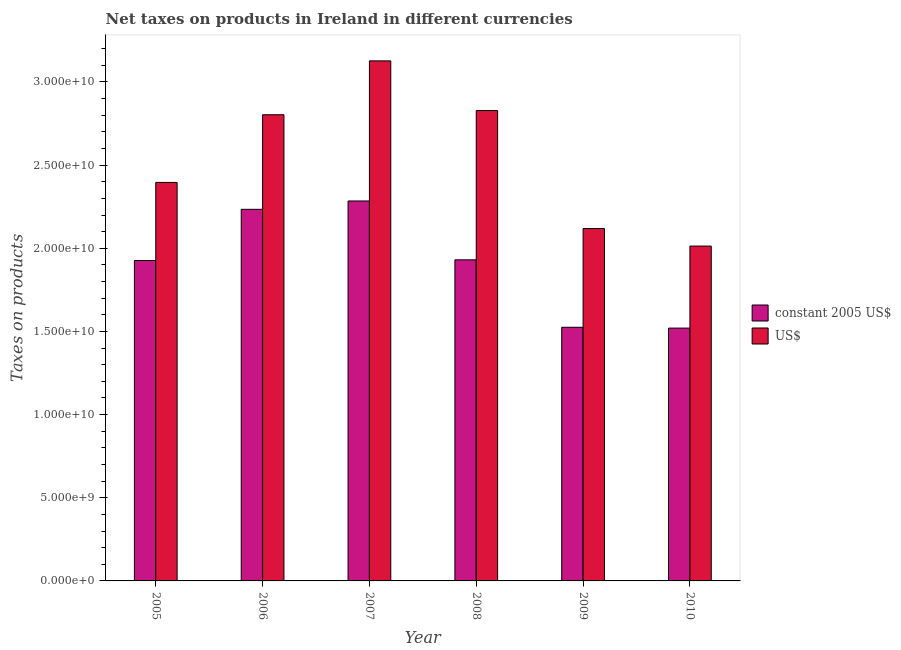How many different coloured bars are there?
Offer a very short reply. 2. Are the number of bars on each tick of the X-axis equal?
Your answer should be compact. Yes. In how many cases, is the number of bars for a given year not equal to the number of legend labels?
Provide a succinct answer. 0. What is the net taxes in us$ in 2008?
Your answer should be compact. 2.83e+1. Across all years, what is the maximum net taxes in us$?
Your answer should be very brief. 3.13e+1. Across all years, what is the minimum net taxes in us$?
Give a very brief answer. 2.01e+1. In which year was the net taxes in constant 2005 us$ maximum?
Keep it short and to the point. 2007. What is the total net taxes in us$ in the graph?
Your response must be concise. 1.53e+11. What is the difference between the net taxes in us$ in 2006 and that in 2010?
Ensure brevity in your answer.  7.90e+09. What is the difference between the net taxes in us$ in 2005 and the net taxes in constant 2005 us$ in 2006?
Offer a terse response. -4.07e+09. What is the average net taxes in us$ per year?
Give a very brief answer. 2.55e+1. In the year 2008, what is the difference between the net taxes in constant 2005 us$ and net taxes in us$?
Your response must be concise. 0. In how many years, is the net taxes in constant 2005 us$ greater than 21000000000 units?
Offer a terse response. 2. What is the ratio of the net taxes in us$ in 2005 to that in 2007?
Offer a terse response. 0.77. Is the net taxes in us$ in 2006 less than that in 2010?
Your answer should be very brief. No. Is the difference between the net taxes in us$ in 2008 and 2010 greater than the difference between the net taxes in constant 2005 us$ in 2008 and 2010?
Offer a terse response. No. What is the difference between the highest and the second highest net taxes in constant 2005 us$?
Provide a short and direct response. 5.02e+08. What is the difference between the highest and the lowest net taxes in constant 2005 us$?
Offer a terse response. 7.64e+09. Is the sum of the net taxes in us$ in 2008 and 2009 greater than the maximum net taxes in constant 2005 us$ across all years?
Make the answer very short. Yes. What does the 1st bar from the left in 2008 represents?
Offer a terse response. Constant 2005 us$. What does the 2nd bar from the right in 2008 represents?
Provide a short and direct response. Constant 2005 us$. Are all the bars in the graph horizontal?
Provide a succinct answer. No. How many years are there in the graph?
Your response must be concise. 6. What is the difference between two consecutive major ticks on the Y-axis?
Give a very brief answer. 5.00e+09. Are the values on the major ticks of Y-axis written in scientific E-notation?
Your answer should be very brief. Yes. How are the legend labels stacked?
Offer a very short reply. Vertical. What is the title of the graph?
Offer a very short reply. Net taxes on products in Ireland in different currencies. Does "Secondary education" appear as one of the legend labels in the graph?
Your answer should be very brief. No. What is the label or title of the Y-axis?
Your answer should be very brief. Taxes on products. What is the Taxes on products of constant 2005 US$ in 2005?
Make the answer very short. 1.93e+1. What is the Taxes on products in US$ in 2005?
Your response must be concise. 2.40e+1. What is the Taxes on products in constant 2005 US$ in 2006?
Your answer should be compact. 2.23e+1. What is the Taxes on products of US$ in 2006?
Make the answer very short. 2.80e+1. What is the Taxes on products in constant 2005 US$ in 2007?
Your answer should be compact. 2.28e+1. What is the Taxes on products in US$ in 2007?
Ensure brevity in your answer.  3.13e+1. What is the Taxes on products in constant 2005 US$ in 2008?
Offer a terse response. 1.93e+1. What is the Taxes on products in US$ in 2008?
Provide a short and direct response. 2.83e+1. What is the Taxes on products in constant 2005 US$ in 2009?
Your answer should be compact. 1.53e+1. What is the Taxes on products of US$ in 2009?
Offer a very short reply. 2.12e+1. What is the Taxes on products in constant 2005 US$ in 2010?
Make the answer very short. 1.52e+1. What is the Taxes on products of US$ in 2010?
Your answer should be compact. 2.01e+1. Across all years, what is the maximum Taxes on products in constant 2005 US$?
Offer a very short reply. 2.28e+1. Across all years, what is the maximum Taxes on products of US$?
Keep it short and to the point. 3.13e+1. Across all years, what is the minimum Taxes on products of constant 2005 US$?
Ensure brevity in your answer.  1.52e+1. Across all years, what is the minimum Taxes on products of US$?
Offer a very short reply. 2.01e+1. What is the total Taxes on products of constant 2005 US$ in the graph?
Provide a short and direct response. 1.14e+11. What is the total Taxes on products of US$ in the graph?
Provide a short and direct response. 1.53e+11. What is the difference between the Taxes on products of constant 2005 US$ in 2005 and that in 2006?
Provide a short and direct response. -3.08e+09. What is the difference between the Taxes on products in US$ in 2005 and that in 2006?
Offer a very short reply. -4.07e+09. What is the difference between the Taxes on products in constant 2005 US$ in 2005 and that in 2007?
Provide a succinct answer. -3.58e+09. What is the difference between the Taxes on products in US$ in 2005 and that in 2007?
Offer a terse response. -7.31e+09. What is the difference between the Taxes on products in constant 2005 US$ in 2005 and that in 2008?
Ensure brevity in your answer.  -4.06e+07. What is the difference between the Taxes on products of US$ in 2005 and that in 2008?
Provide a succinct answer. -4.32e+09. What is the difference between the Taxes on products in constant 2005 US$ in 2005 and that in 2009?
Offer a very short reply. 4.02e+09. What is the difference between the Taxes on products of US$ in 2005 and that in 2009?
Keep it short and to the point. 2.77e+09. What is the difference between the Taxes on products in constant 2005 US$ in 2005 and that in 2010?
Make the answer very short. 4.07e+09. What is the difference between the Taxes on products of US$ in 2005 and that in 2010?
Your response must be concise. 3.83e+09. What is the difference between the Taxes on products in constant 2005 US$ in 2006 and that in 2007?
Ensure brevity in your answer.  -5.02e+08. What is the difference between the Taxes on products in US$ in 2006 and that in 2007?
Make the answer very short. -3.24e+09. What is the difference between the Taxes on products of constant 2005 US$ in 2006 and that in 2008?
Provide a succinct answer. 3.04e+09. What is the difference between the Taxes on products of US$ in 2006 and that in 2008?
Your answer should be very brief. -2.50e+08. What is the difference between the Taxes on products in constant 2005 US$ in 2006 and that in 2009?
Provide a succinct answer. 7.09e+09. What is the difference between the Taxes on products in US$ in 2006 and that in 2009?
Give a very brief answer. 6.84e+09. What is the difference between the Taxes on products of constant 2005 US$ in 2006 and that in 2010?
Ensure brevity in your answer.  7.14e+09. What is the difference between the Taxes on products of US$ in 2006 and that in 2010?
Your answer should be compact. 7.90e+09. What is the difference between the Taxes on products of constant 2005 US$ in 2007 and that in 2008?
Provide a short and direct response. 3.54e+09. What is the difference between the Taxes on products of US$ in 2007 and that in 2008?
Your response must be concise. 2.99e+09. What is the difference between the Taxes on products in constant 2005 US$ in 2007 and that in 2009?
Ensure brevity in your answer.  7.59e+09. What is the difference between the Taxes on products in US$ in 2007 and that in 2009?
Your answer should be very brief. 1.01e+1. What is the difference between the Taxes on products in constant 2005 US$ in 2007 and that in 2010?
Offer a terse response. 7.64e+09. What is the difference between the Taxes on products in US$ in 2007 and that in 2010?
Make the answer very short. 1.11e+1. What is the difference between the Taxes on products of constant 2005 US$ in 2008 and that in 2009?
Provide a short and direct response. 4.06e+09. What is the difference between the Taxes on products in US$ in 2008 and that in 2009?
Ensure brevity in your answer.  7.09e+09. What is the difference between the Taxes on products of constant 2005 US$ in 2008 and that in 2010?
Keep it short and to the point. 4.11e+09. What is the difference between the Taxes on products in US$ in 2008 and that in 2010?
Make the answer very short. 8.15e+09. What is the difference between the Taxes on products in constant 2005 US$ in 2009 and that in 2010?
Provide a short and direct response. 4.93e+07. What is the difference between the Taxes on products in US$ in 2009 and that in 2010?
Offer a very short reply. 1.05e+09. What is the difference between the Taxes on products of constant 2005 US$ in 2005 and the Taxes on products of US$ in 2006?
Provide a succinct answer. -8.76e+09. What is the difference between the Taxes on products in constant 2005 US$ in 2005 and the Taxes on products in US$ in 2007?
Your answer should be very brief. -1.20e+1. What is the difference between the Taxes on products in constant 2005 US$ in 2005 and the Taxes on products in US$ in 2008?
Offer a terse response. -9.01e+09. What is the difference between the Taxes on products in constant 2005 US$ in 2005 and the Taxes on products in US$ in 2009?
Make the answer very short. -1.92e+09. What is the difference between the Taxes on products in constant 2005 US$ in 2005 and the Taxes on products in US$ in 2010?
Your response must be concise. -8.67e+08. What is the difference between the Taxes on products in constant 2005 US$ in 2006 and the Taxes on products in US$ in 2007?
Make the answer very short. -8.93e+09. What is the difference between the Taxes on products of constant 2005 US$ in 2006 and the Taxes on products of US$ in 2008?
Your response must be concise. -5.94e+09. What is the difference between the Taxes on products of constant 2005 US$ in 2006 and the Taxes on products of US$ in 2009?
Give a very brief answer. 1.16e+09. What is the difference between the Taxes on products in constant 2005 US$ in 2006 and the Taxes on products in US$ in 2010?
Your answer should be very brief. 2.21e+09. What is the difference between the Taxes on products in constant 2005 US$ in 2007 and the Taxes on products in US$ in 2008?
Your answer should be very brief. -5.44e+09. What is the difference between the Taxes on products of constant 2005 US$ in 2007 and the Taxes on products of US$ in 2009?
Your response must be concise. 1.66e+09. What is the difference between the Taxes on products in constant 2005 US$ in 2007 and the Taxes on products in US$ in 2010?
Your answer should be compact. 2.71e+09. What is the difference between the Taxes on products of constant 2005 US$ in 2008 and the Taxes on products of US$ in 2009?
Ensure brevity in your answer.  -1.88e+09. What is the difference between the Taxes on products of constant 2005 US$ in 2008 and the Taxes on products of US$ in 2010?
Make the answer very short. -8.27e+08. What is the difference between the Taxes on products of constant 2005 US$ in 2009 and the Taxes on products of US$ in 2010?
Keep it short and to the point. -4.88e+09. What is the average Taxes on products of constant 2005 US$ per year?
Ensure brevity in your answer.  1.90e+1. What is the average Taxes on products in US$ per year?
Give a very brief answer. 2.55e+1. In the year 2005, what is the difference between the Taxes on products of constant 2005 US$ and Taxes on products of US$?
Give a very brief answer. -4.69e+09. In the year 2006, what is the difference between the Taxes on products in constant 2005 US$ and Taxes on products in US$?
Provide a short and direct response. -5.69e+09. In the year 2007, what is the difference between the Taxes on products of constant 2005 US$ and Taxes on products of US$?
Offer a terse response. -8.42e+09. In the year 2008, what is the difference between the Taxes on products in constant 2005 US$ and Taxes on products in US$?
Keep it short and to the point. -8.97e+09. In the year 2009, what is the difference between the Taxes on products of constant 2005 US$ and Taxes on products of US$?
Your response must be concise. -5.94e+09. In the year 2010, what is the difference between the Taxes on products in constant 2005 US$ and Taxes on products in US$?
Provide a succinct answer. -4.93e+09. What is the ratio of the Taxes on products of constant 2005 US$ in 2005 to that in 2006?
Ensure brevity in your answer.  0.86. What is the ratio of the Taxes on products of US$ in 2005 to that in 2006?
Ensure brevity in your answer.  0.85. What is the ratio of the Taxes on products in constant 2005 US$ in 2005 to that in 2007?
Make the answer very short. 0.84. What is the ratio of the Taxes on products in US$ in 2005 to that in 2007?
Keep it short and to the point. 0.77. What is the ratio of the Taxes on products in US$ in 2005 to that in 2008?
Give a very brief answer. 0.85. What is the ratio of the Taxes on products of constant 2005 US$ in 2005 to that in 2009?
Keep it short and to the point. 1.26. What is the ratio of the Taxes on products of US$ in 2005 to that in 2009?
Give a very brief answer. 1.13. What is the ratio of the Taxes on products of constant 2005 US$ in 2005 to that in 2010?
Provide a succinct answer. 1.27. What is the ratio of the Taxes on products in US$ in 2005 to that in 2010?
Your answer should be compact. 1.19. What is the ratio of the Taxes on products in US$ in 2006 to that in 2007?
Your response must be concise. 0.9. What is the ratio of the Taxes on products in constant 2005 US$ in 2006 to that in 2008?
Give a very brief answer. 1.16. What is the ratio of the Taxes on products in US$ in 2006 to that in 2008?
Offer a terse response. 0.99. What is the ratio of the Taxes on products of constant 2005 US$ in 2006 to that in 2009?
Give a very brief answer. 1.47. What is the ratio of the Taxes on products of US$ in 2006 to that in 2009?
Offer a terse response. 1.32. What is the ratio of the Taxes on products in constant 2005 US$ in 2006 to that in 2010?
Keep it short and to the point. 1.47. What is the ratio of the Taxes on products in US$ in 2006 to that in 2010?
Give a very brief answer. 1.39. What is the ratio of the Taxes on products in constant 2005 US$ in 2007 to that in 2008?
Provide a succinct answer. 1.18. What is the ratio of the Taxes on products in US$ in 2007 to that in 2008?
Make the answer very short. 1.11. What is the ratio of the Taxes on products of constant 2005 US$ in 2007 to that in 2009?
Give a very brief answer. 1.5. What is the ratio of the Taxes on products in US$ in 2007 to that in 2009?
Offer a very short reply. 1.48. What is the ratio of the Taxes on products in constant 2005 US$ in 2007 to that in 2010?
Your response must be concise. 1.5. What is the ratio of the Taxes on products of US$ in 2007 to that in 2010?
Offer a terse response. 1.55. What is the ratio of the Taxes on products in constant 2005 US$ in 2008 to that in 2009?
Your response must be concise. 1.27. What is the ratio of the Taxes on products of US$ in 2008 to that in 2009?
Provide a short and direct response. 1.33. What is the ratio of the Taxes on products of constant 2005 US$ in 2008 to that in 2010?
Keep it short and to the point. 1.27. What is the ratio of the Taxes on products in US$ in 2008 to that in 2010?
Offer a very short reply. 1.4. What is the ratio of the Taxes on products of constant 2005 US$ in 2009 to that in 2010?
Your answer should be compact. 1. What is the ratio of the Taxes on products in US$ in 2009 to that in 2010?
Your answer should be compact. 1.05. What is the difference between the highest and the second highest Taxes on products of constant 2005 US$?
Your answer should be compact. 5.02e+08. What is the difference between the highest and the second highest Taxes on products of US$?
Provide a succinct answer. 2.99e+09. What is the difference between the highest and the lowest Taxes on products of constant 2005 US$?
Provide a succinct answer. 7.64e+09. What is the difference between the highest and the lowest Taxes on products of US$?
Keep it short and to the point. 1.11e+1. 